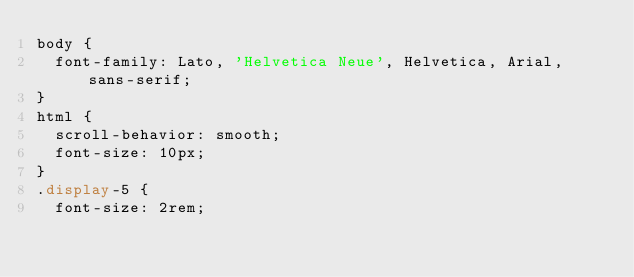Convert code to text. <code><loc_0><loc_0><loc_500><loc_500><_CSS_>body {
  font-family: Lato, 'Helvetica Neue', Helvetica, Arial, sans-serif;
}
html {
  scroll-behavior: smooth;
  font-size: 10px;
}
.display-5 {
  font-size: 2rem;</code> 